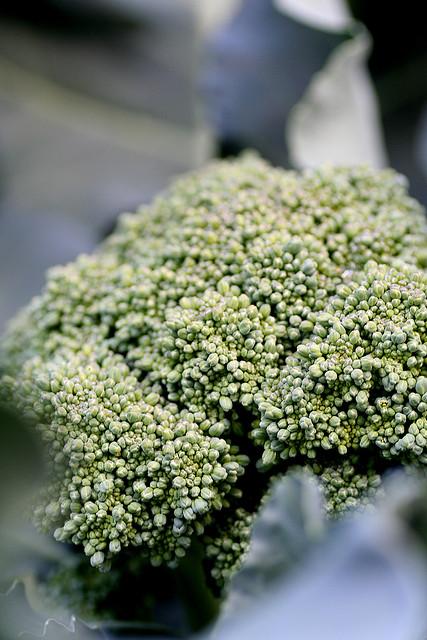What color is the vegetable?
Give a very brief answer. Green. What vegetable is this?
Be succinct. Broccoli. What is the main subject of this photo?
Short answer required. Broccoli. 